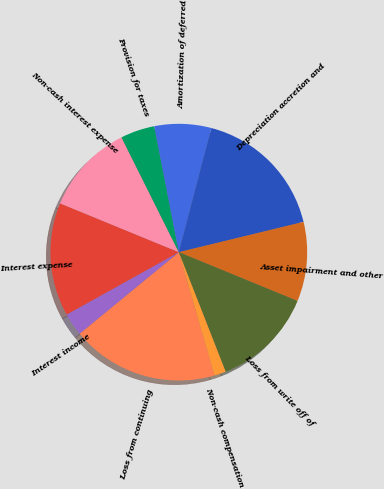Convert chart. <chart><loc_0><loc_0><loc_500><loc_500><pie_chart><fcel>Loss from continuing<fcel>Interest income<fcel>Interest expense<fcel>Non-cash interest expense<fcel>Provision for taxes<fcel>Amortization of deferred<fcel>Depreciation accretion and<fcel>Asset impairment and other<fcel>Loss from write off of<fcel>Non-cash compensation<nl><fcel>18.55%<fcel>2.87%<fcel>14.28%<fcel>11.43%<fcel>4.3%<fcel>7.15%<fcel>17.13%<fcel>10.0%<fcel>12.85%<fcel>1.45%<nl></chart> 